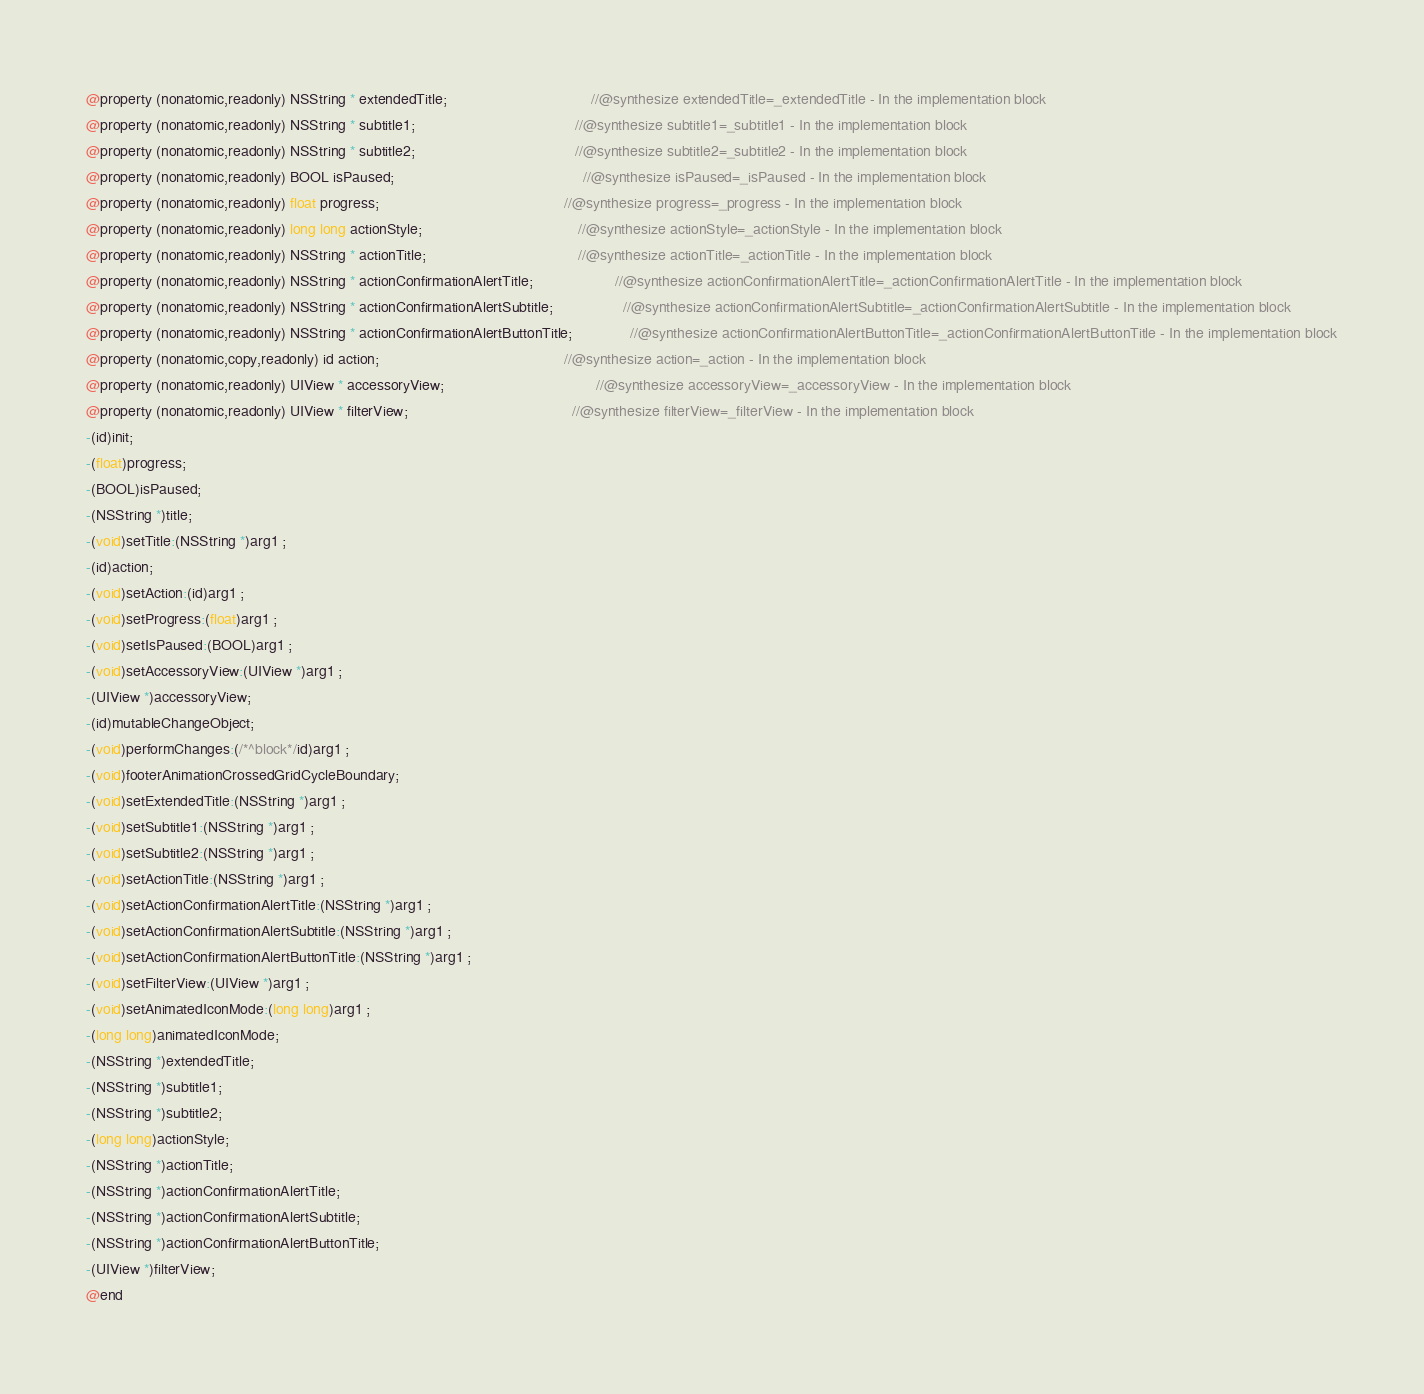<code> <loc_0><loc_0><loc_500><loc_500><_C_>@property (nonatomic,readonly) NSString * extendedTitle;                                   //@synthesize extendedTitle=_extendedTitle - In the implementation block
@property (nonatomic,readonly) NSString * subtitle1;                                       //@synthesize subtitle1=_subtitle1 - In the implementation block
@property (nonatomic,readonly) NSString * subtitle2;                                       //@synthesize subtitle2=_subtitle2 - In the implementation block
@property (nonatomic,readonly) BOOL isPaused;                                              //@synthesize isPaused=_isPaused - In the implementation block
@property (nonatomic,readonly) float progress;                                             //@synthesize progress=_progress - In the implementation block
@property (nonatomic,readonly) long long actionStyle;                                      //@synthesize actionStyle=_actionStyle - In the implementation block
@property (nonatomic,readonly) NSString * actionTitle;                                     //@synthesize actionTitle=_actionTitle - In the implementation block
@property (nonatomic,readonly) NSString * actionConfirmationAlertTitle;                    //@synthesize actionConfirmationAlertTitle=_actionConfirmationAlertTitle - In the implementation block
@property (nonatomic,readonly) NSString * actionConfirmationAlertSubtitle;                 //@synthesize actionConfirmationAlertSubtitle=_actionConfirmationAlertSubtitle - In the implementation block
@property (nonatomic,readonly) NSString * actionConfirmationAlertButtonTitle;              //@synthesize actionConfirmationAlertButtonTitle=_actionConfirmationAlertButtonTitle - In the implementation block
@property (nonatomic,copy,readonly) id action;                                             //@synthesize action=_action - In the implementation block
@property (nonatomic,readonly) UIView * accessoryView;                                     //@synthesize accessoryView=_accessoryView - In the implementation block
@property (nonatomic,readonly) UIView * filterView;                                        //@synthesize filterView=_filterView - In the implementation block
-(id)init;
-(float)progress;
-(BOOL)isPaused;
-(NSString *)title;
-(void)setTitle:(NSString *)arg1 ;
-(id)action;
-(void)setAction:(id)arg1 ;
-(void)setProgress:(float)arg1 ;
-(void)setIsPaused:(BOOL)arg1 ;
-(void)setAccessoryView:(UIView *)arg1 ;
-(UIView *)accessoryView;
-(id)mutableChangeObject;
-(void)performChanges:(/*^block*/id)arg1 ;
-(void)footerAnimationCrossedGridCycleBoundary;
-(void)setExtendedTitle:(NSString *)arg1 ;
-(void)setSubtitle1:(NSString *)arg1 ;
-(void)setSubtitle2:(NSString *)arg1 ;
-(void)setActionTitle:(NSString *)arg1 ;
-(void)setActionConfirmationAlertTitle:(NSString *)arg1 ;
-(void)setActionConfirmationAlertSubtitle:(NSString *)arg1 ;
-(void)setActionConfirmationAlertButtonTitle:(NSString *)arg1 ;
-(void)setFilterView:(UIView *)arg1 ;
-(void)setAnimatedIconMode:(long long)arg1 ;
-(long long)animatedIconMode;
-(NSString *)extendedTitle;
-(NSString *)subtitle1;
-(NSString *)subtitle2;
-(long long)actionStyle;
-(NSString *)actionTitle;
-(NSString *)actionConfirmationAlertTitle;
-(NSString *)actionConfirmationAlertSubtitle;
-(NSString *)actionConfirmationAlertButtonTitle;
-(UIView *)filterView;
@end

</code> 